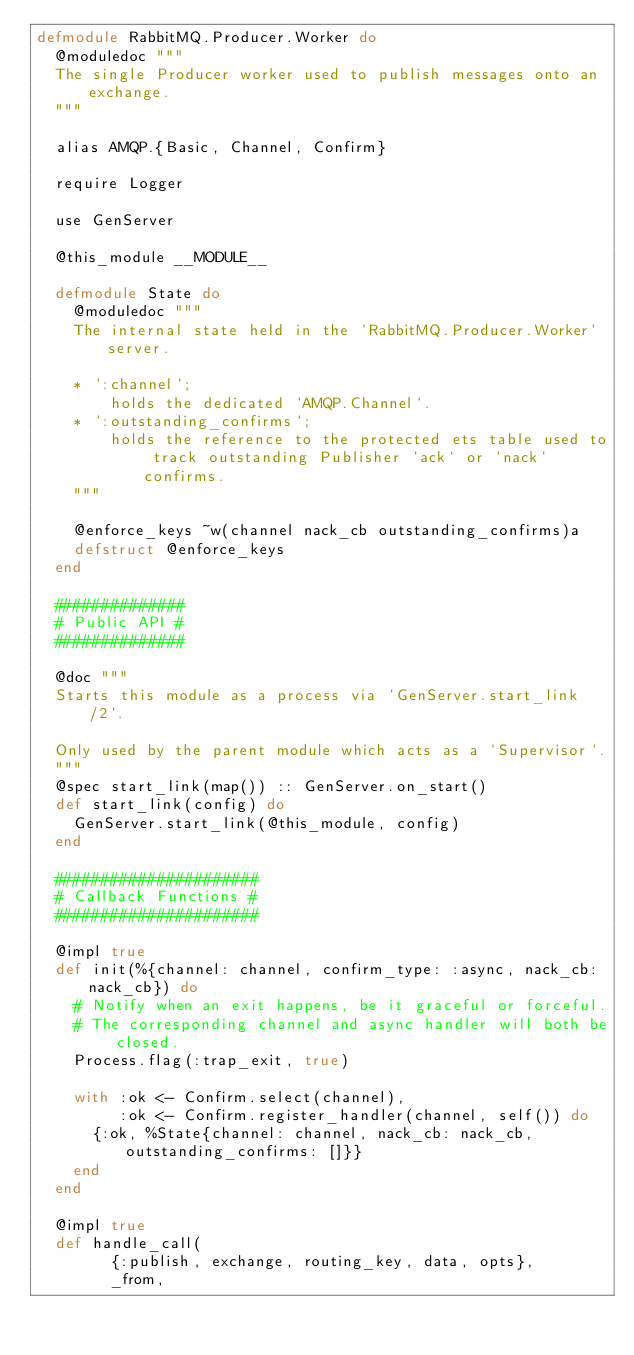<code> <loc_0><loc_0><loc_500><loc_500><_Elixir_>defmodule RabbitMQ.Producer.Worker do
  @moduledoc """
  The single Producer worker used to publish messages onto an exchange.
  """

  alias AMQP.{Basic, Channel, Confirm}

  require Logger

  use GenServer

  @this_module __MODULE__

  defmodule State do
    @moduledoc """
    The internal state held in the `RabbitMQ.Producer.Worker` server.

    * `:channel`;
        holds the dedicated `AMQP.Channel`.
    * `:outstanding_confirms`;
        holds the reference to the protected ets table used to track outstanding Publisher `ack` or `nack` confirms.
    """

    @enforce_keys ~w(channel nack_cb outstanding_confirms)a
    defstruct @enforce_keys
  end

  ##############
  # Public API #
  ##############

  @doc """
  Starts this module as a process via `GenServer.start_link/2`.

  Only used by the parent module which acts as a `Supervisor`.
  """
  @spec start_link(map()) :: GenServer.on_start()
  def start_link(config) do
    GenServer.start_link(@this_module, config)
  end

  ######################
  # Callback Functions #
  ######################

  @impl true
  def init(%{channel: channel, confirm_type: :async, nack_cb: nack_cb}) do
    # Notify when an exit happens, be it graceful or forceful.
    # The corresponding channel and async handler will both be closed.
    Process.flag(:trap_exit, true)

    with :ok <- Confirm.select(channel),
         :ok <- Confirm.register_handler(channel, self()) do
      {:ok, %State{channel: channel, nack_cb: nack_cb, outstanding_confirms: []}}
    end
  end

  @impl true
  def handle_call(
        {:publish, exchange, routing_key, data, opts},
        _from,</code> 